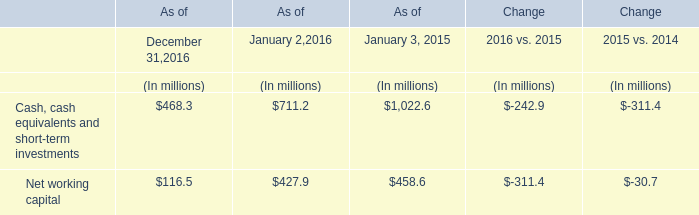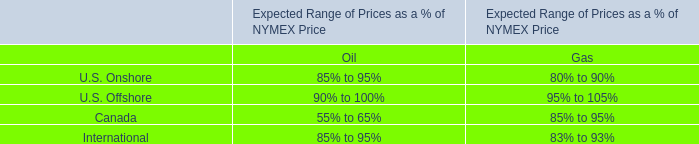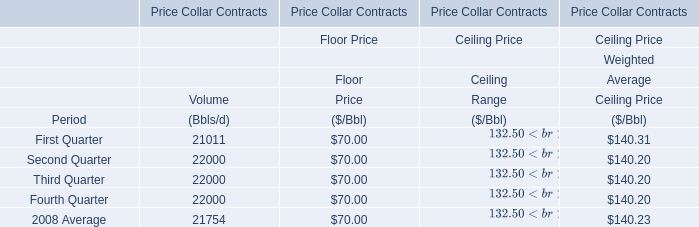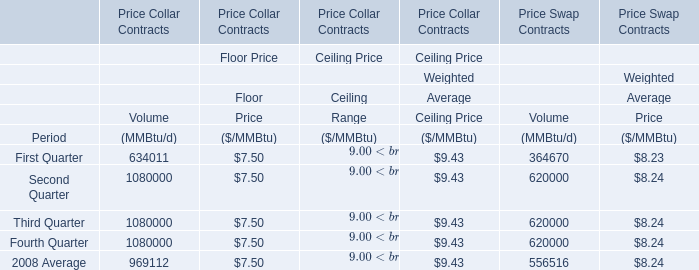What was the total amount of First Quarter, Second Quarter, Third Quarter and Fourth Quarter for Floor Price? 
Computations: (((70 + 70) + 70) + 70)
Answer: 280.0. 